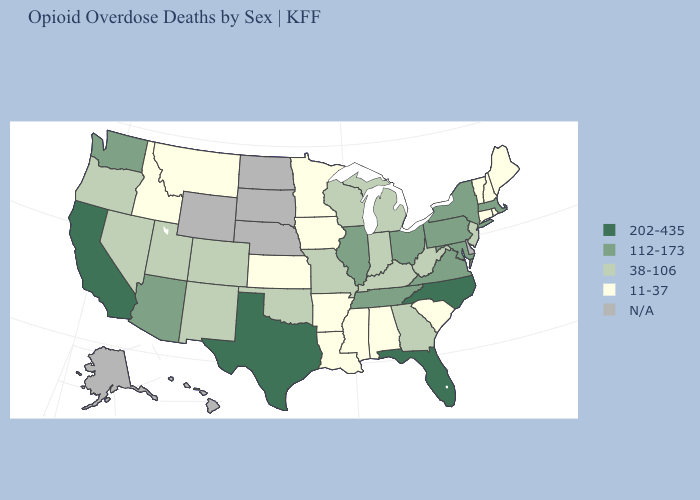Name the states that have a value in the range N/A?
Concise answer only. Alaska, Delaware, Hawaii, Nebraska, North Dakota, South Dakota, Wyoming. Which states have the lowest value in the USA?
Short answer required. Alabama, Arkansas, Connecticut, Idaho, Iowa, Kansas, Louisiana, Maine, Minnesota, Mississippi, Montana, New Hampshire, Rhode Island, South Carolina, Vermont. What is the highest value in the Northeast ?
Short answer required. 112-173. What is the value of Arkansas?
Be succinct. 11-37. Does Idaho have the highest value in the West?
Write a very short answer. No. Does Washington have the lowest value in the West?
Write a very short answer. No. Does Montana have the lowest value in the West?
Answer briefly. Yes. What is the lowest value in states that border Maine?
Give a very brief answer. 11-37. Name the states that have a value in the range 11-37?
Answer briefly. Alabama, Arkansas, Connecticut, Idaho, Iowa, Kansas, Louisiana, Maine, Minnesota, Mississippi, Montana, New Hampshire, Rhode Island, South Carolina, Vermont. Does the map have missing data?
Answer briefly. Yes. What is the value of Maine?
Be succinct. 11-37. Among the states that border Kansas , which have the highest value?
Give a very brief answer. Colorado, Missouri, Oklahoma. What is the value of Virginia?
Keep it brief. 112-173. 